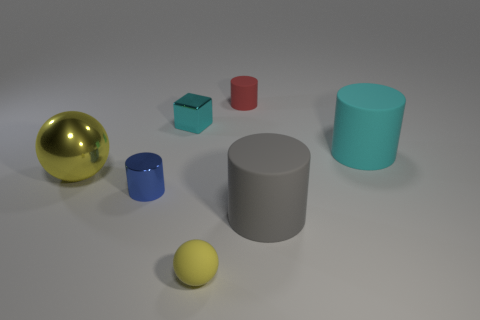There is a tiny shiny object in front of the small cyan metal object; what color is it?
Your answer should be compact. Blue. Is the tiny yellow rubber object the same shape as the blue thing?
Keep it short and to the point. No. What is the color of the cylinder that is both behind the metal sphere and in front of the block?
Give a very brief answer. Cyan. There is a cyan thing that is in front of the tiny cube; is its size the same as the sphere in front of the small blue shiny thing?
Provide a succinct answer. No. How many objects are objects that are right of the yellow rubber thing or small cubes?
Provide a short and direct response. 4. What is the red cylinder made of?
Offer a very short reply. Rubber. Does the metallic cylinder have the same size as the block?
Offer a very short reply. Yes. How many blocks are big cyan objects or large blue metal objects?
Your answer should be compact. 0. The tiny matte thing that is behind the cyan matte object that is to the right of the big gray object is what color?
Your answer should be very brief. Red. Is the number of red matte cylinders that are right of the gray cylinder less than the number of cyan shiny things that are in front of the large cyan cylinder?
Offer a very short reply. No. 